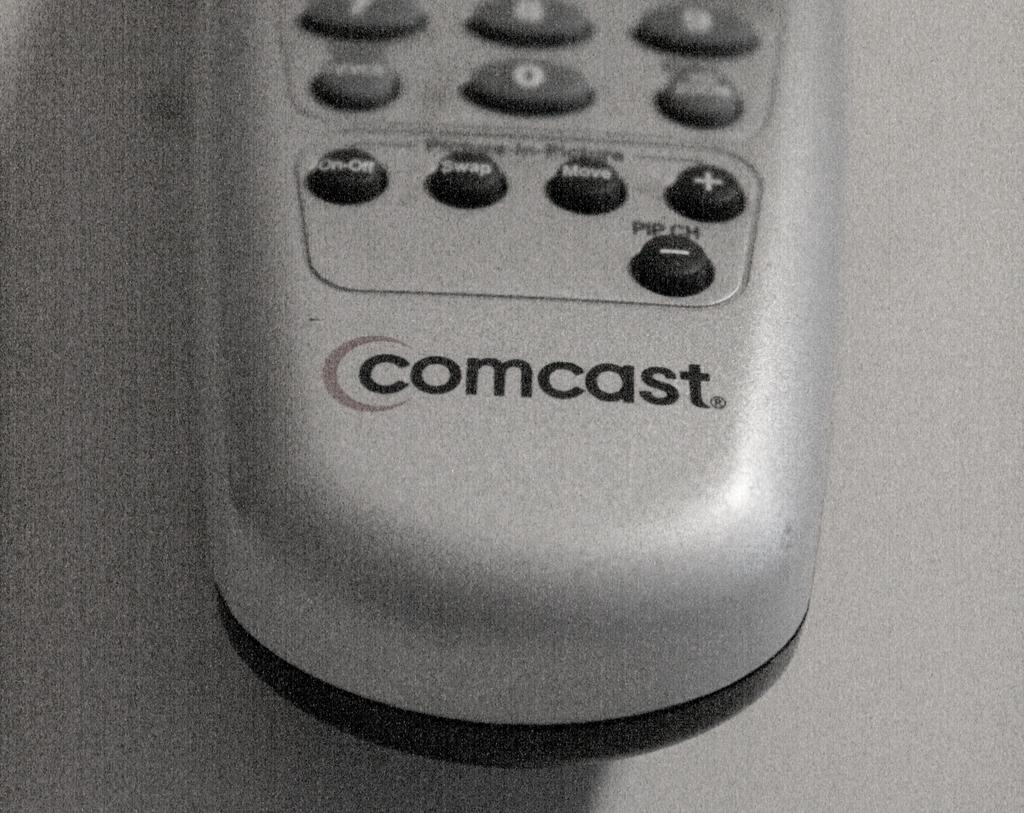<image>
Present a compact description of the photo's key features. The television remote control is for use with Comcast Cable. 